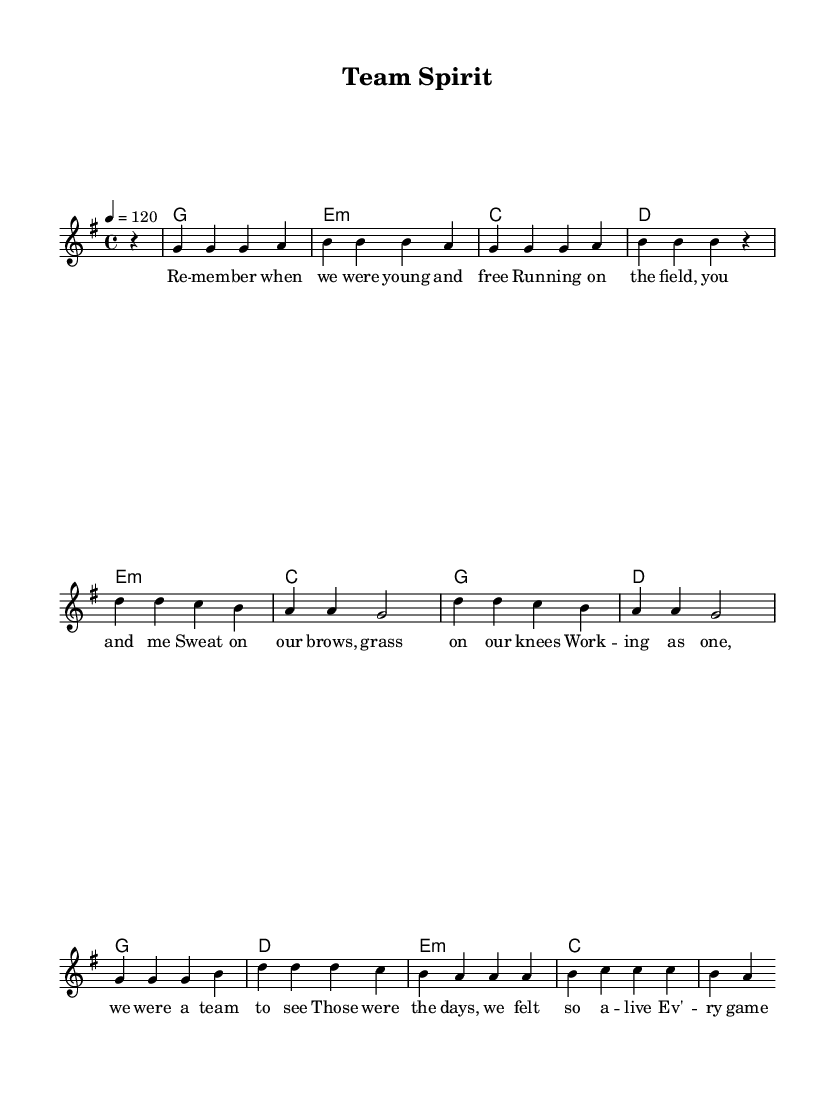what is the key signature of this music? The key signature is G major, which contains one sharp (F#). This is determined by looking at the key signature indicated at the beginning of the sheet music.
Answer: G major what is the time signature of this music? The time signature is 4/4, which is indicated at the beginning of the sheet music. This means there are four beats in each measure and a quarter note receives one beat.
Answer: 4/4 what is the tempo marking of this piece? The tempo marking is 120 beats per minute. This is indicated under the tempo section at the beginning of the music, which shows how fast the piece should be played.
Answer: 120 how many measures are in the verse section? The verse section consists of four measures. This is counted by examining the bar lines in the melody section where the verse lyrics are located.
Answer: 4 what chord follows the 'g' in the chorus? The chord that follows the 'g' in the chorus is 'd'. This is found by examining the harmonies layer, specifically looking at the sequence right after the melody note.
Answer: d how does the pre-chorus relate to the verse in terms of melody? The pre-chorus uses similar notes as the verse but alters the rhythmic pattern. It starts on d and transitions, indicating a shift in energy. This analysis requires comparing the melody lines of both sections side by side.
Answer: similar notes, altered rhythm what is the main theme of the lyrics in this song? The main theme of the lyrics revolves around teamwork and nostalgia for childhood sports. This is derived from the recurring phrases in the lyrics which highlight unity and shared experiences in sports.
Answer: teamwork and nostalgia 